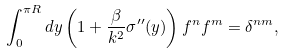Convert formula to latex. <formula><loc_0><loc_0><loc_500><loc_500>\int _ { 0 } ^ { \pi R } d y \left ( 1 + \frac { \beta } { k ^ { 2 } } \sigma ^ { \prime \prime } ( y ) \right ) f ^ { n } f ^ { m } = \delta ^ { n m } ,</formula> 